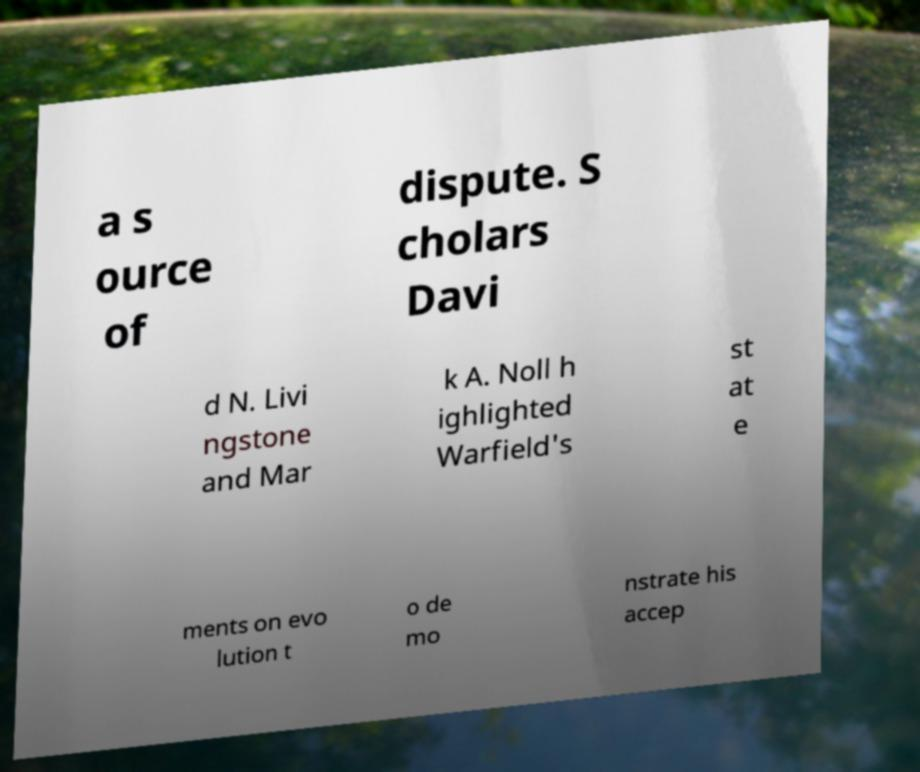Could you assist in decoding the text presented in this image and type it out clearly? a s ource of dispute. S cholars Davi d N. Livi ngstone and Mar k A. Noll h ighlighted Warfield's st at e ments on evo lution t o de mo nstrate his accep 